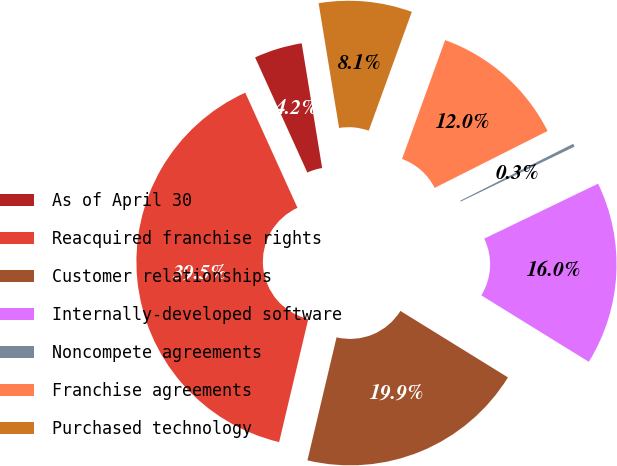Convert chart. <chart><loc_0><loc_0><loc_500><loc_500><pie_chart><fcel>As of April 30<fcel>Reacquired franchise rights<fcel>Customer relationships<fcel>Internally-developed software<fcel>Noncompete agreements<fcel>Franchise agreements<fcel>Purchased technology<nl><fcel>4.19%<fcel>39.52%<fcel>19.89%<fcel>15.97%<fcel>0.27%<fcel>12.04%<fcel>8.12%<nl></chart> 